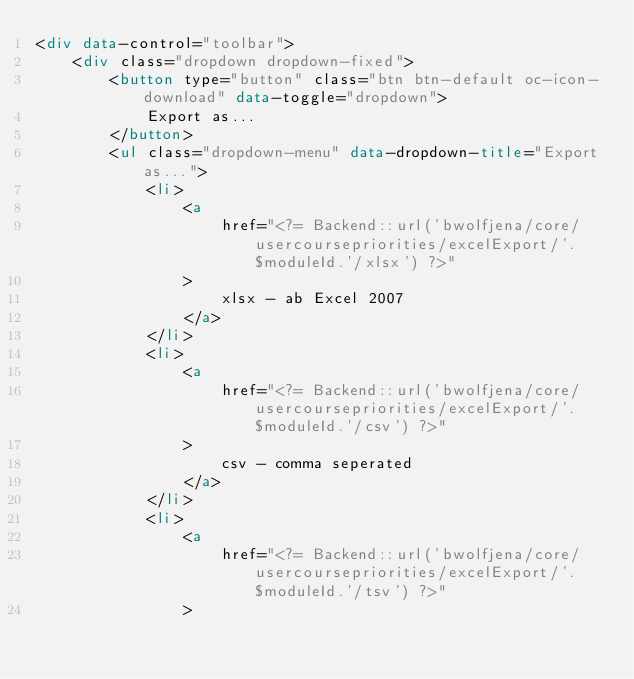<code> <loc_0><loc_0><loc_500><loc_500><_HTML_><div data-control="toolbar">
    <div class="dropdown dropdown-fixed">
        <button type="button" class="btn btn-default oc-icon-download" data-toggle="dropdown">
            Export as...
        </button>
        <ul class="dropdown-menu" data-dropdown-title="Export as...">
            <li>
                <a
                    href="<?= Backend::url('bwolfjena/core/usercoursepriorities/excelExport/'.$moduleId.'/xlsx') ?>"
                >
                    xlsx - ab Excel 2007
                </a>
            </li>
            <li>
                <a
                    href="<?= Backend::url('bwolfjena/core/usercoursepriorities/excelExport/'.$moduleId.'/csv') ?>"
                >
                    csv - comma seperated
                </a>
            </li>
            <li>
                <a
                    href="<?= Backend::url('bwolfjena/core/usercoursepriorities/excelExport/'.$moduleId.'/tsv') ?>"
                ></code> 